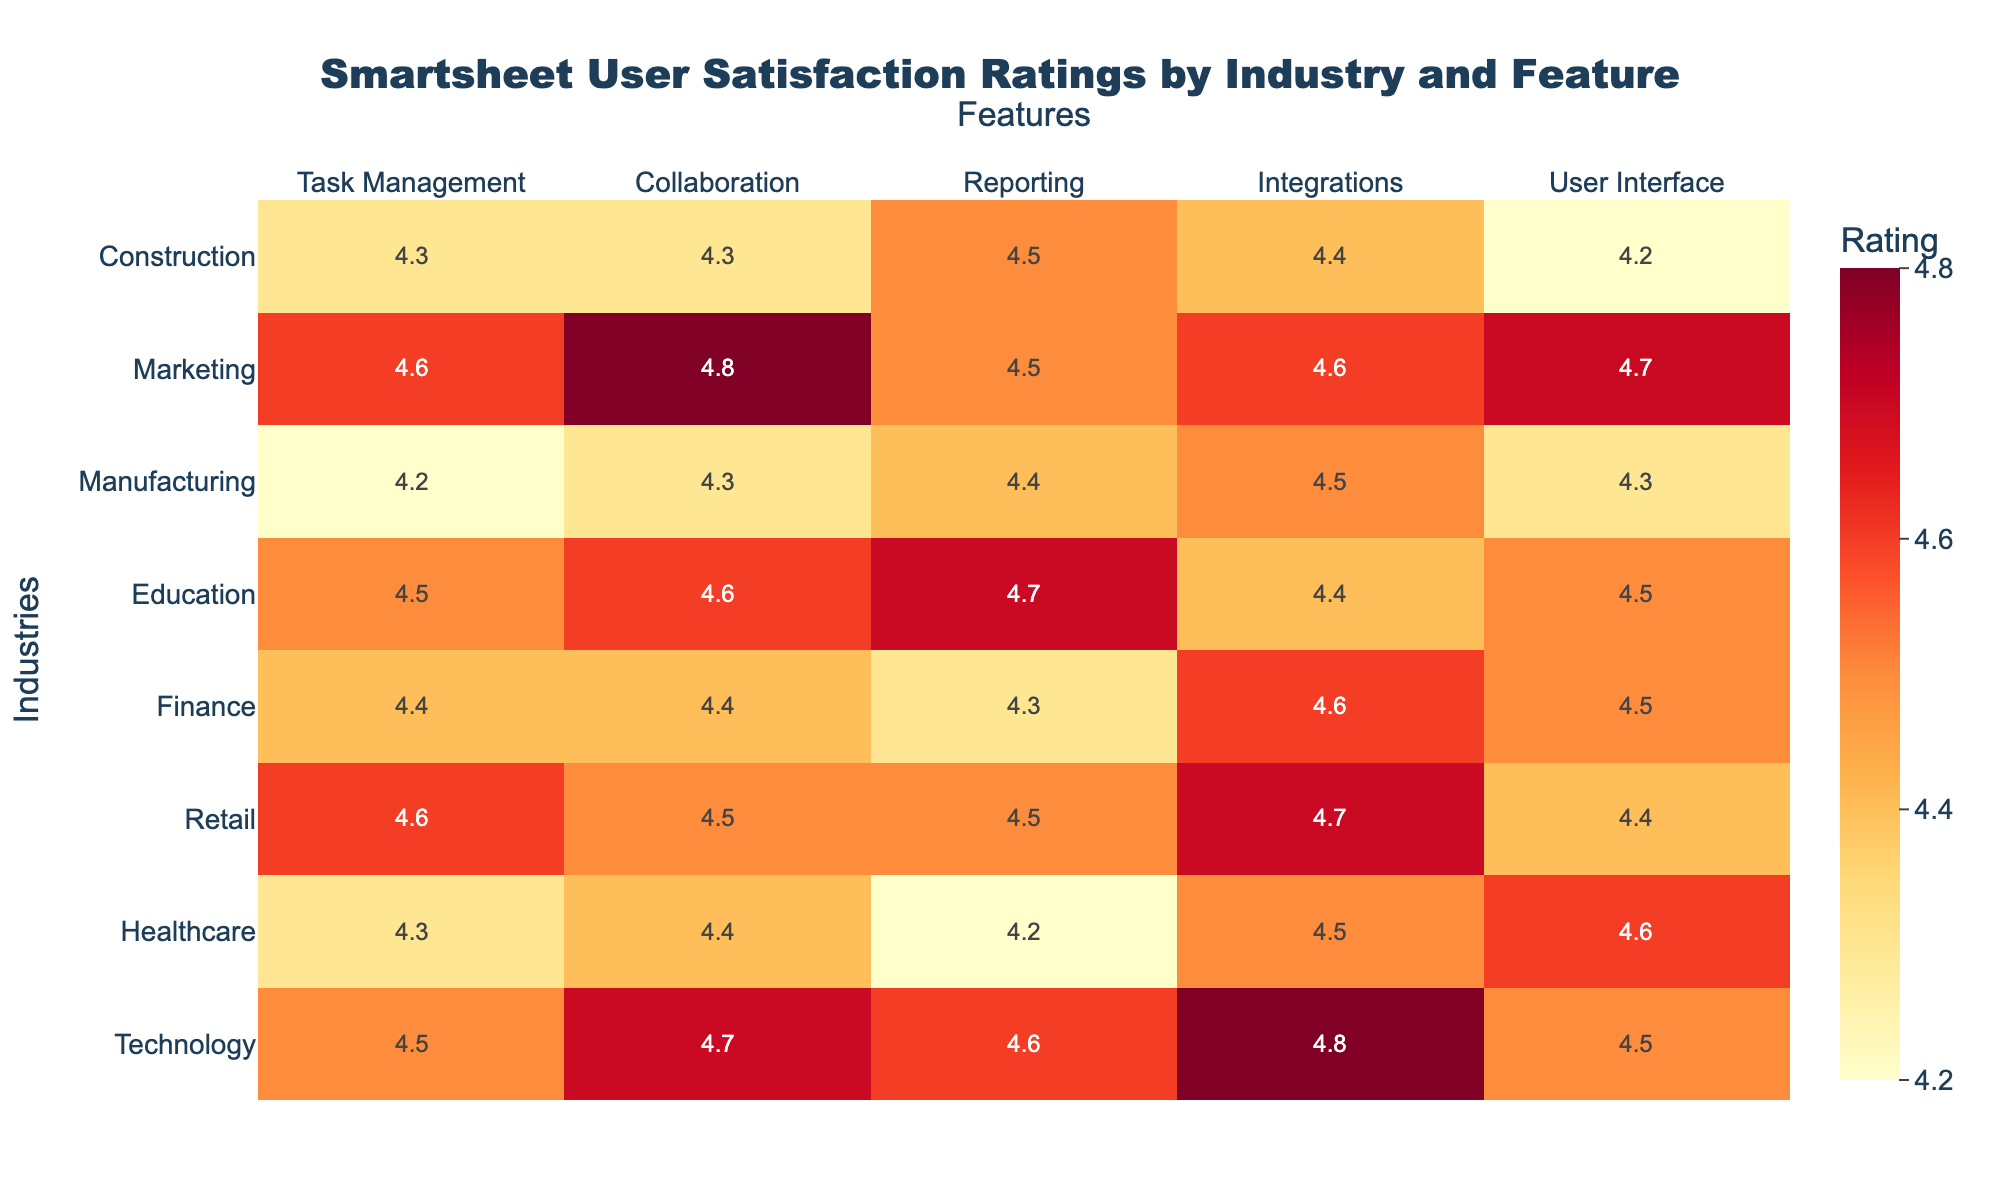What is the user satisfaction rating for Collaboration in the Finance industry? The rating for Collaboration in the Finance industry is directly taken from the table where the Finance row is checked. The value under the Collaboration column is 4.4.
Answer: 4.4 Which industry has the highest rating for Task Management? By looking at the Task Management column, the highest rating is in the Retail industry, which has a rating of 4.6.
Answer: Retail What is the average rating for Reporting across all industries? The ratings for Reporting are: Technology (4.6), Healthcare (4.2), Retail (4.5), Finance (4.3), Education (4.7), Manufacturing (4.4), Marketing (4.5), and Construction (4.5). Summing these values gives 4.6 + 4.2 + 4.5 + 4.3 + 4.7 + 4.4 + 4.5 + 4.5 = 35.7. Dividing by the number of industries (8) gives an average of 35.7/8 = 4.4625, which can be rounded to 4.5.
Answer: 4.5 Is the user interface rating for Manufacturing higher than that of Healthcare? The user interface rating for Manufacturing is 4.3 and for Healthcare is 4.6. Since 4.3 is less than 4.6, the statement is false.
Answer: No Which industry has the lowest rating for Integrations? The Integrations ratings are: Technology (4.8), Healthcare (4.5), Retail (4.7), Finance (4.6), Education (4.4), Manufacturing (4.5), Marketing (4.6), and Construction (4.4). The lowest value is in Education at 4.4.
Answer: Education What is the difference in user satisfaction ratings for Collaboration between Marketing and Education? Looking at the Collaboration ratings, Marketing has a rating of 4.8 and Education has a rating of 4.6. The difference is calculated as 4.8 - 4.6 = 0.2.
Answer: 0.2 Which feature has the lowest satisfaction rating in the Manufacturing industry? In the Manufacturing row, the feature ratings are: Task Management (4.2), Collaboration (4.3), Reporting (4.4), Integrations (4.5), User Interface (4.3). The lowest rating here is for Task Management, which is 4.2.
Answer: Task Management Are all industries rated above 4 for the feature Reporting? Checking the Reporting ratings for each industry, we find the following values: Technology (4.6), Healthcare (4.2), Retail (4.5), Finance (4.3), Education (4.7), Manufacturing (4.4), Marketing (4.5), and Construction (4.5). The Healthcare rating of 4.2 is below 4, thus the statement is false.
Answer: No 